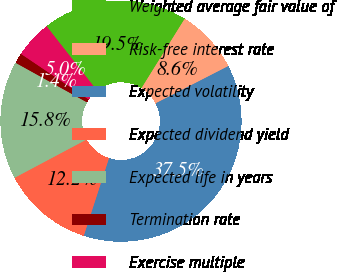Convert chart to OTSL. <chart><loc_0><loc_0><loc_500><loc_500><pie_chart><fcel>Weighted average fair value of<fcel>Risk-free interest rate<fcel>Expected volatility<fcel>Expected dividend yield<fcel>Expected life in years<fcel>Termination rate<fcel>Exercise multiple<nl><fcel>19.45%<fcel>8.6%<fcel>37.54%<fcel>12.22%<fcel>15.83%<fcel>1.37%<fcel>4.99%<nl></chart> 